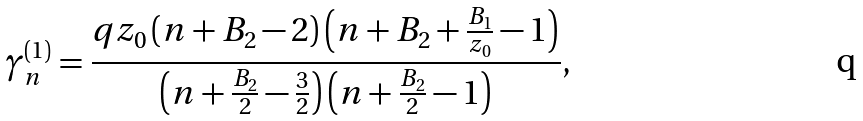<formula> <loc_0><loc_0><loc_500><loc_500>\gamma _ { n } ^ { ( 1 ) } = \frac { q z _ { 0 } \left ( n + B _ { 2 } - 2 \right ) \left ( n + B _ { 2 } + \frac { B _ { 1 } } { z _ { 0 } } - 1 \right ) } { \left ( n + \frac { B _ { 2 } } { 2 } - \frac { 3 } { 2 } \right ) \left ( n + \frac { B _ { 2 } } { 2 } - 1 \right ) } ,</formula> 